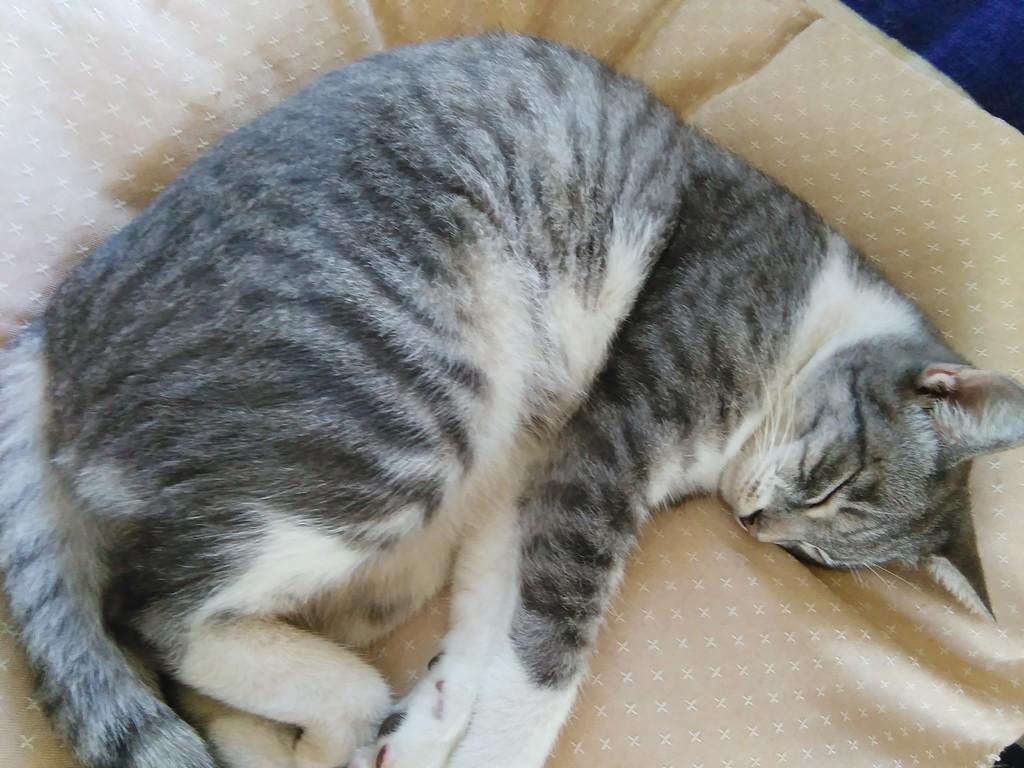Can you describe this image briefly? In this image I can see a cat laying on a bed. 